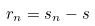<formula> <loc_0><loc_0><loc_500><loc_500>r _ { n } = s _ { n } - s</formula> 